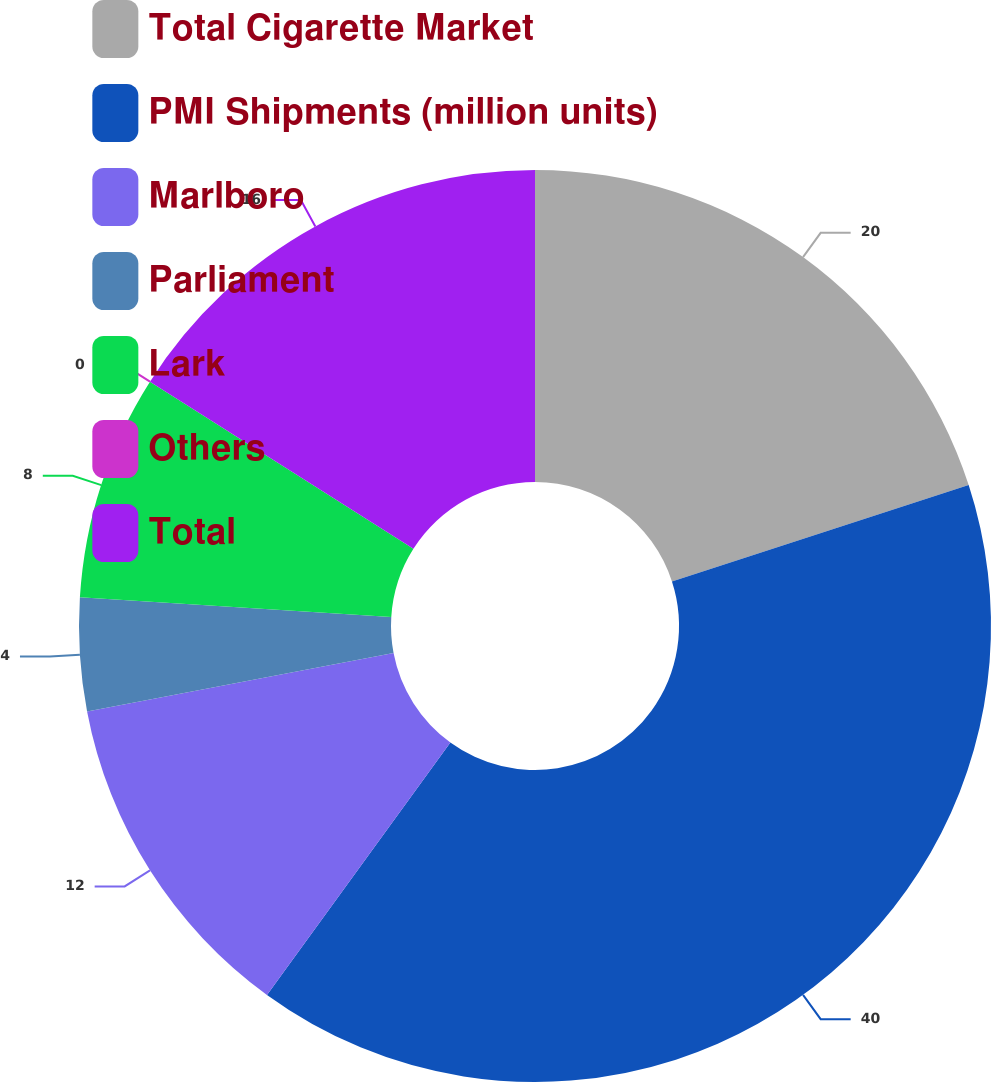Convert chart to OTSL. <chart><loc_0><loc_0><loc_500><loc_500><pie_chart><fcel>Total Cigarette Market<fcel>PMI Shipments (million units)<fcel>Marlboro<fcel>Parliament<fcel>Lark<fcel>Others<fcel>Total<nl><fcel>20.0%<fcel>40.0%<fcel>12.0%<fcel>4.0%<fcel>8.0%<fcel>0.0%<fcel>16.0%<nl></chart> 